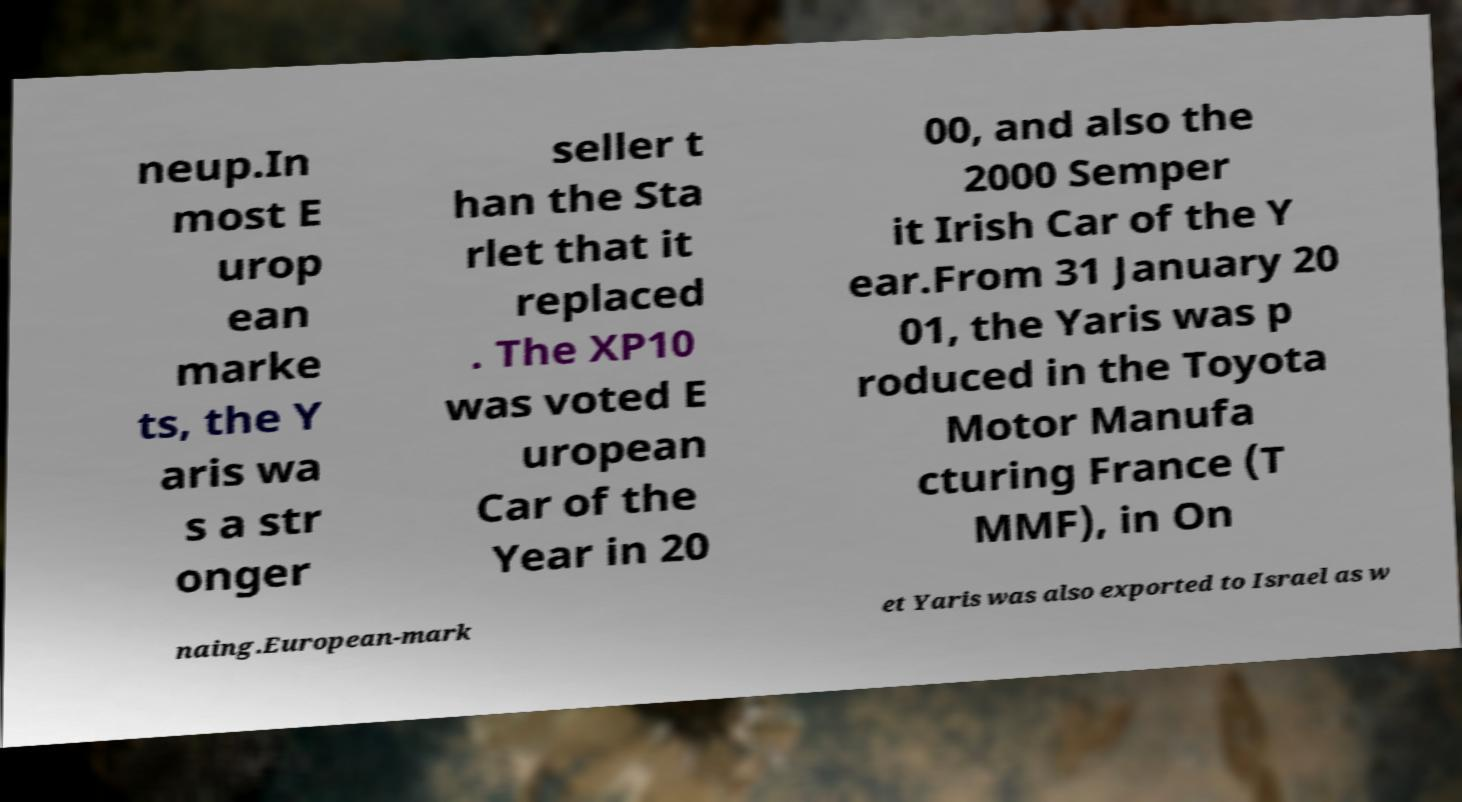Could you assist in decoding the text presented in this image and type it out clearly? neup.In most E urop ean marke ts, the Y aris wa s a str onger seller t han the Sta rlet that it replaced . The XP10 was voted E uropean Car of the Year in 20 00, and also the 2000 Semper it Irish Car of the Y ear.From 31 January 20 01, the Yaris was p roduced in the Toyota Motor Manufa cturing France (T MMF), in On naing.European-mark et Yaris was also exported to Israel as w 